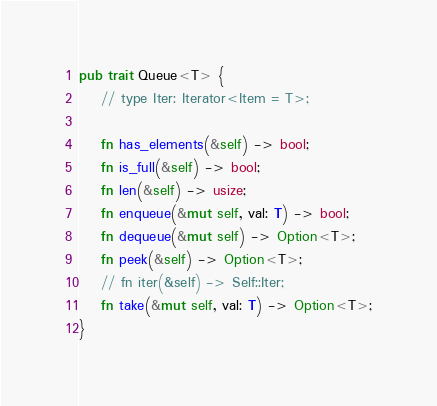Convert code to text. <code><loc_0><loc_0><loc_500><loc_500><_Rust_>pub trait Queue<T> {
    // type Iter: Iterator<Item = T>;

    fn has_elements(&self) -> bool;
    fn is_full(&self) -> bool;
    fn len(&self) -> usize;
    fn enqueue(&mut self, val: T) -> bool;
    fn dequeue(&mut self) -> Option<T>;
    fn peek(&self) -> Option<T>;
    // fn iter(&self) -> Self::Iter;
    fn take(&mut self, val: T) -> Option<T>;
}</code> 